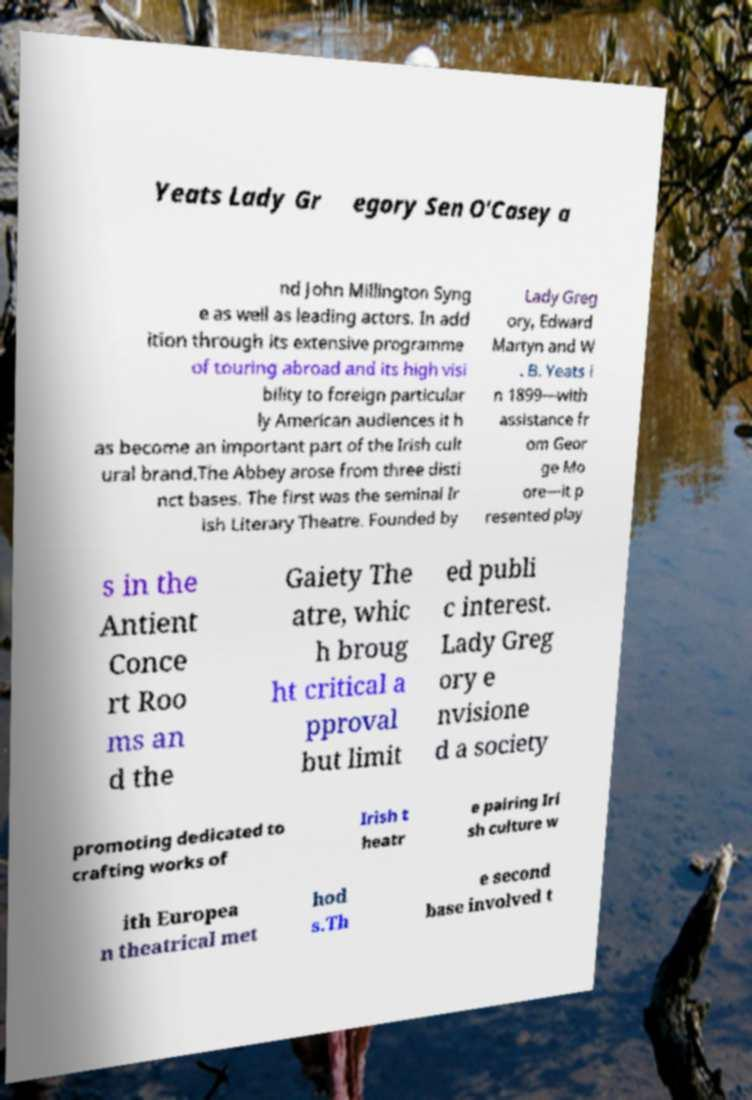There's text embedded in this image that I need extracted. Can you transcribe it verbatim? Yeats Lady Gr egory Sen O'Casey a nd John Millington Syng e as well as leading actors. In add ition through its extensive programme of touring abroad and its high visi bility to foreign particular ly American audiences it h as become an important part of the Irish cult ural brand.The Abbey arose from three disti nct bases. The first was the seminal Ir ish Literary Theatre. Founded by Lady Greg ory, Edward Martyn and W . B. Yeats i n 1899—with assistance fr om Geor ge Mo ore—it p resented play s in the Antient Conce rt Roo ms an d the Gaiety The atre, whic h broug ht critical a pproval but limit ed publi c interest. Lady Greg ory e nvisione d a society promoting dedicated to crafting works of Irish t heatr e pairing Iri sh culture w ith Europea n theatrical met hod s.Th e second base involved t 